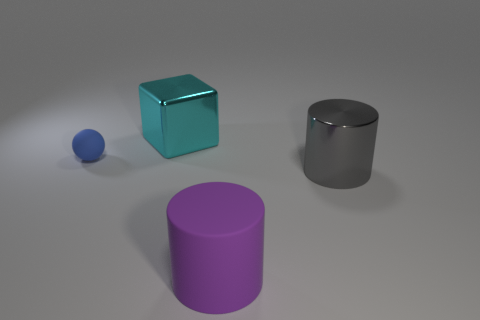There is a metal object in front of the matte ball; is it the same color as the large cylinder left of the gray cylinder?
Your answer should be very brief. No. What color is the object that is both to the left of the rubber cylinder and in front of the metal cube?
Offer a very short reply. Blue. What number of other things are there of the same shape as the large gray thing?
Ensure brevity in your answer.  1. There is a shiny cube that is the same size as the gray metal thing; what color is it?
Provide a short and direct response. Cyan. What color is the shiny thing that is to the right of the cyan shiny cube?
Your response must be concise. Gray. Are there any large rubber cylinders to the right of the big metallic thing that is in front of the cyan shiny thing?
Provide a succinct answer. No. There is a large cyan metallic object; is its shape the same as the shiny object that is in front of the blue rubber ball?
Your response must be concise. No. What size is the thing that is both left of the big matte thing and in front of the cyan metallic thing?
Offer a very short reply. Small. Is there a big purple ball made of the same material as the gray cylinder?
Your response must be concise. No. There is a object to the left of the large object that is behind the big gray thing; what is it made of?
Make the answer very short. Rubber. 